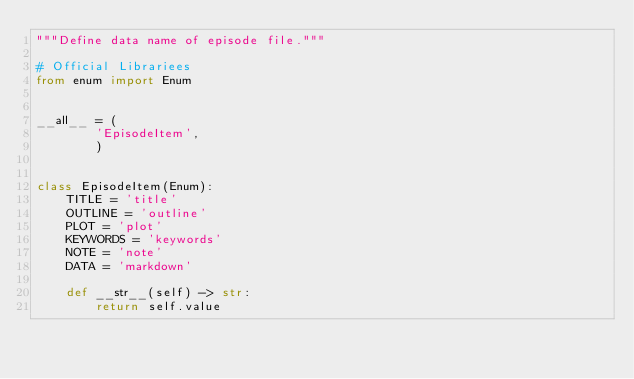Convert code to text. <code><loc_0><loc_0><loc_500><loc_500><_Python_>"""Define data name of episode file."""

# Official Librariees
from enum import Enum


__all__ = (
        'EpisodeItem',
        )


class EpisodeItem(Enum):
    TITLE = 'title'
    OUTLINE = 'outline'
    PLOT = 'plot'
    KEYWORDS = 'keywords'
    NOTE = 'note'
    DATA = 'markdown'

    def __str__(self) -> str:
        return self.value
</code> 